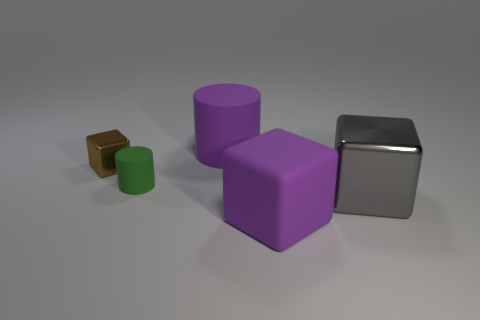Does the purple rubber cylinder have the same size as the gray object?
Offer a terse response. Yes. How many objects are things that are to the right of the large cylinder or big purple matte objects that are behind the gray block?
Ensure brevity in your answer.  3. Is the number of small green rubber things on the left side of the tiny green object greater than the number of big green metal cubes?
Ensure brevity in your answer.  No. What number of other objects are there of the same shape as the brown shiny thing?
Give a very brief answer. 2. There is a big object that is on the left side of the big metallic object and right of the purple matte cylinder; what is it made of?
Offer a very short reply. Rubber. What number of objects are either tiny blue cylinders or big purple rubber cylinders?
Offer a terse response. 1. Are there more red cylinders than matte objects?
Offer a very short reply. No. There is a cube that is to the left of the large purple object that is in front of the small metallic object; what is its size?
Your answer should be very brief. Small. There is another big object that is the same shape as the green rubber thing; what is its color?
Keep it short and to the point. Purple. What size is the brown cube?
Your answer should be very brief. Small. 